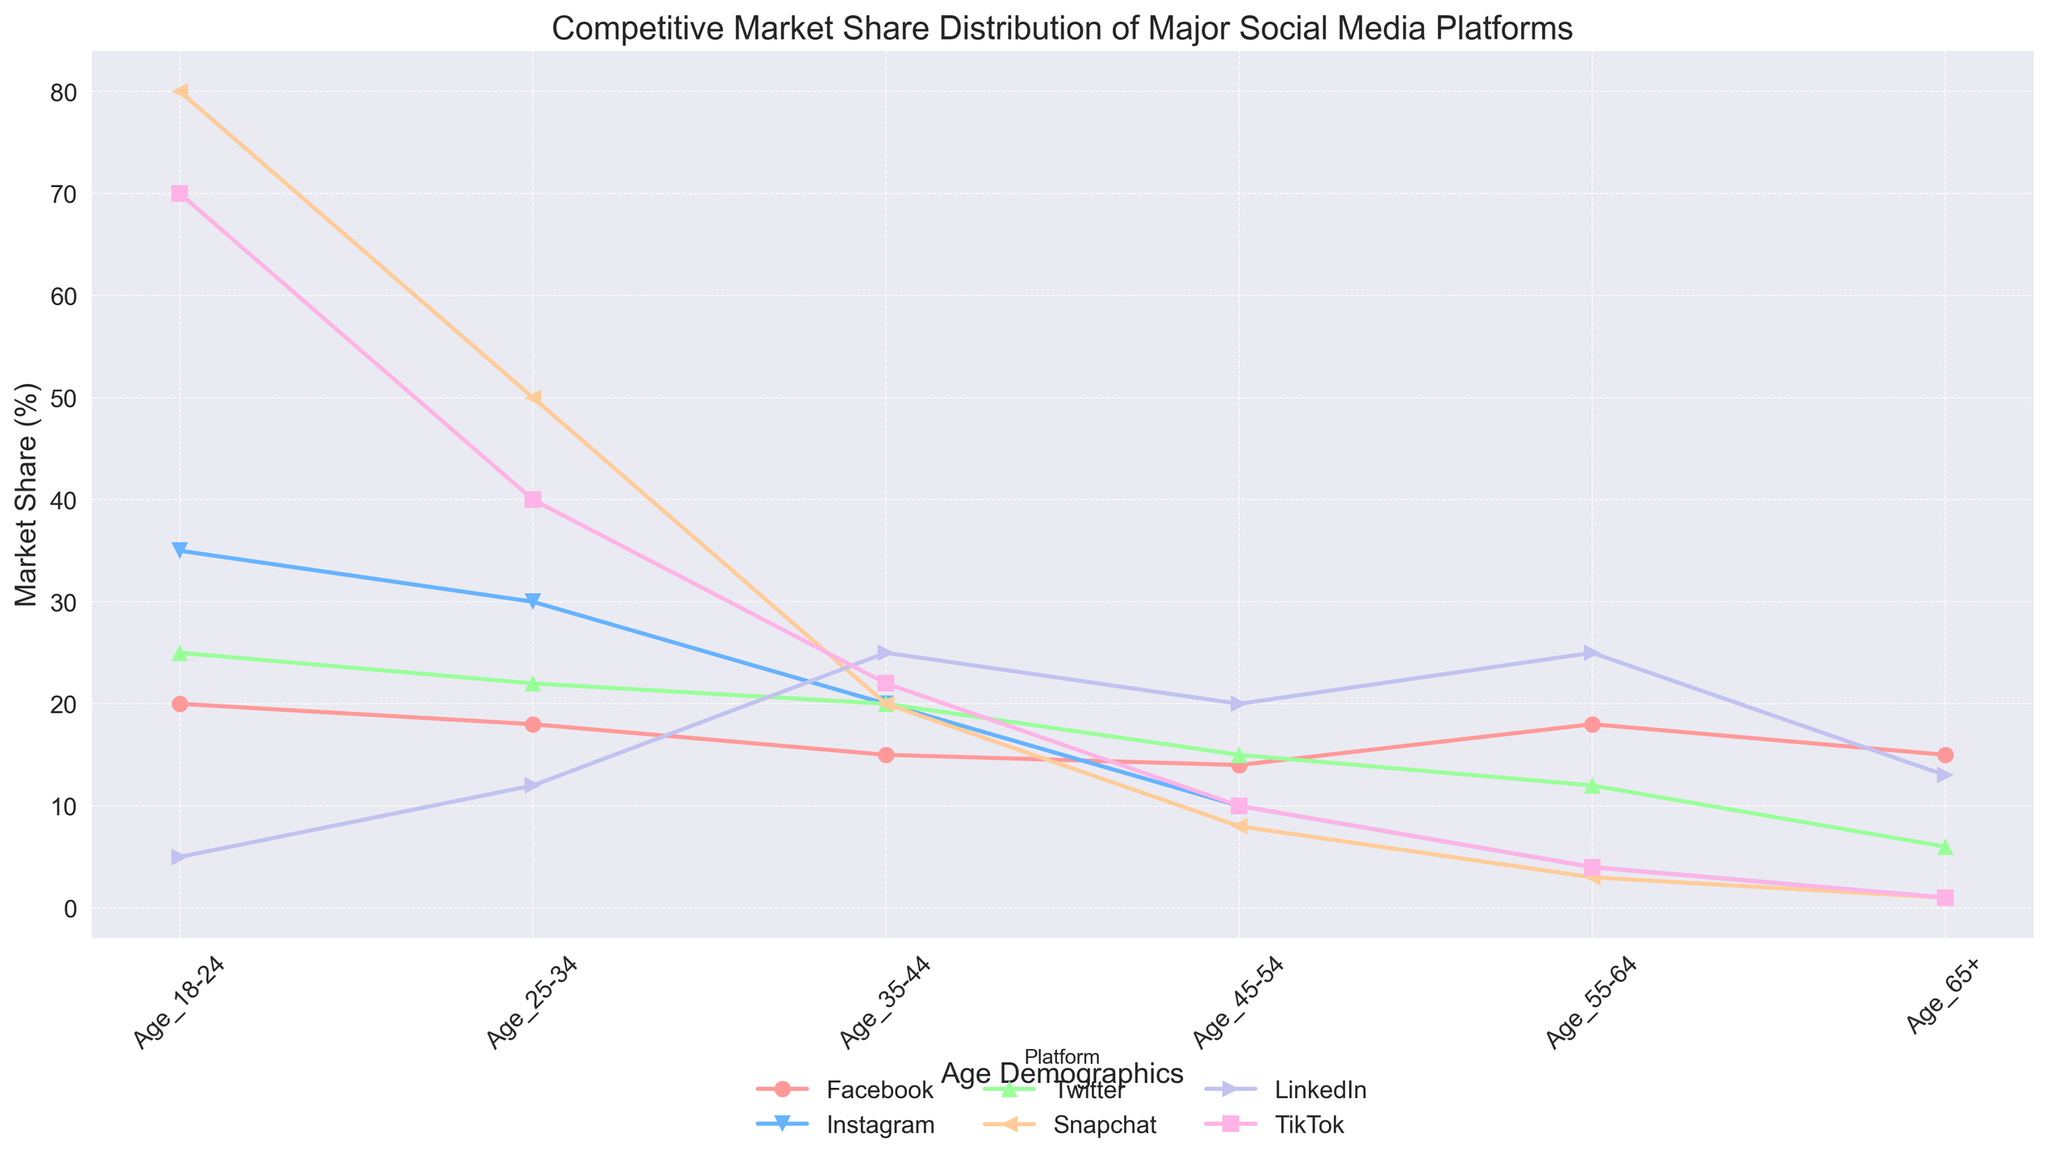What platform has the highest market share among the 18-24 age group? Looking at the figure, the platform with the highest line for the 18-24 age group is Snapchat.
Answer: Snapchat Which age group has the highest market share for LinkedIn? Observing the graph, LinkedIn peaks at the age group 35-44 and 55-64.
Answer: 35-44 and 55-64 By how much does Twitter's market share decrease from the 18-24 age group to the 65+ age group? Twitter's market share for the 18-24 age group is 25%. For the 65+ age group, it is 6%. The decrease is 25% - 6% = 19%.
Answer: 19% Which platform shows a steep decline in market share as the age increases? The platforms with noticeable declines in their lines are Snapchat and TikTok, especially noticeable as age increases from 18-24 to 65+.
Answer: Snapchat and TikTok Is Instagram more popular than Twitter among the 25-34 age group? Comparing the lines, Instagram has a higher value (30%) than Twitter (22%) for the 25-34 age group.
Answer: Yes What is the average market share for Facebook across all age demographics? Facebook's market shares are 20, 18, 15, 14, 18, and 15. The average is (20+18+15+14+18+15)/6 = 100/6 ≈ 16.67%.
Answer: 16.67% How does Snapchat's market share for the 45-54 age group compare to LinkedIn's for the same age group? For the 45-54 age group, Snapchat's market share is 8%, while LinkedIn's is 20%. Snapchat's share is significantly smaller.
Answer: Snapchat's share is smaller Which platform has the lowest market share among the 55-64 age group? Observing the graph, the platform with the lowest line for the 55-64 age group is both Snapchat and TikTok with 3% and 4% respectively.
Answer: Snapchat and TikTok Do Facebook and Instagram have similar market shares in any age group? Facebook (18%) and Instagram (15%) are closest in market share within the 35-44 age group.
Answer: Yes, in 35-44 age group 